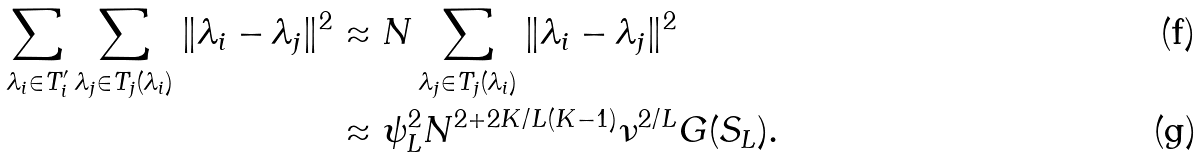<formula> <loc_0><loc_0><loc_500><loc_500>\sum _ { \lambda _ { i } \in T ^ { \prime } _ { i } } \sum _ { \lambda _ { j } \in T _ { j } ( \lambda _ { i } ) } \| \lambda _ { i } - \lambda _ { j } \| ^ { 2 } & \approx N \sum _ { \lambda _ { j } \in T _ { j } ( \lambda _ { i } ) } \| \lambda _ { i } - \lambda _ { j } \| ^ { 2 } \\ & \approx \psi _ { L } ^ { 2 } N ^ { 2 + 2 K / L ( K - 1 ) } \nu ^ { 2 / L } G ( S _ { L } ) .</formula> 